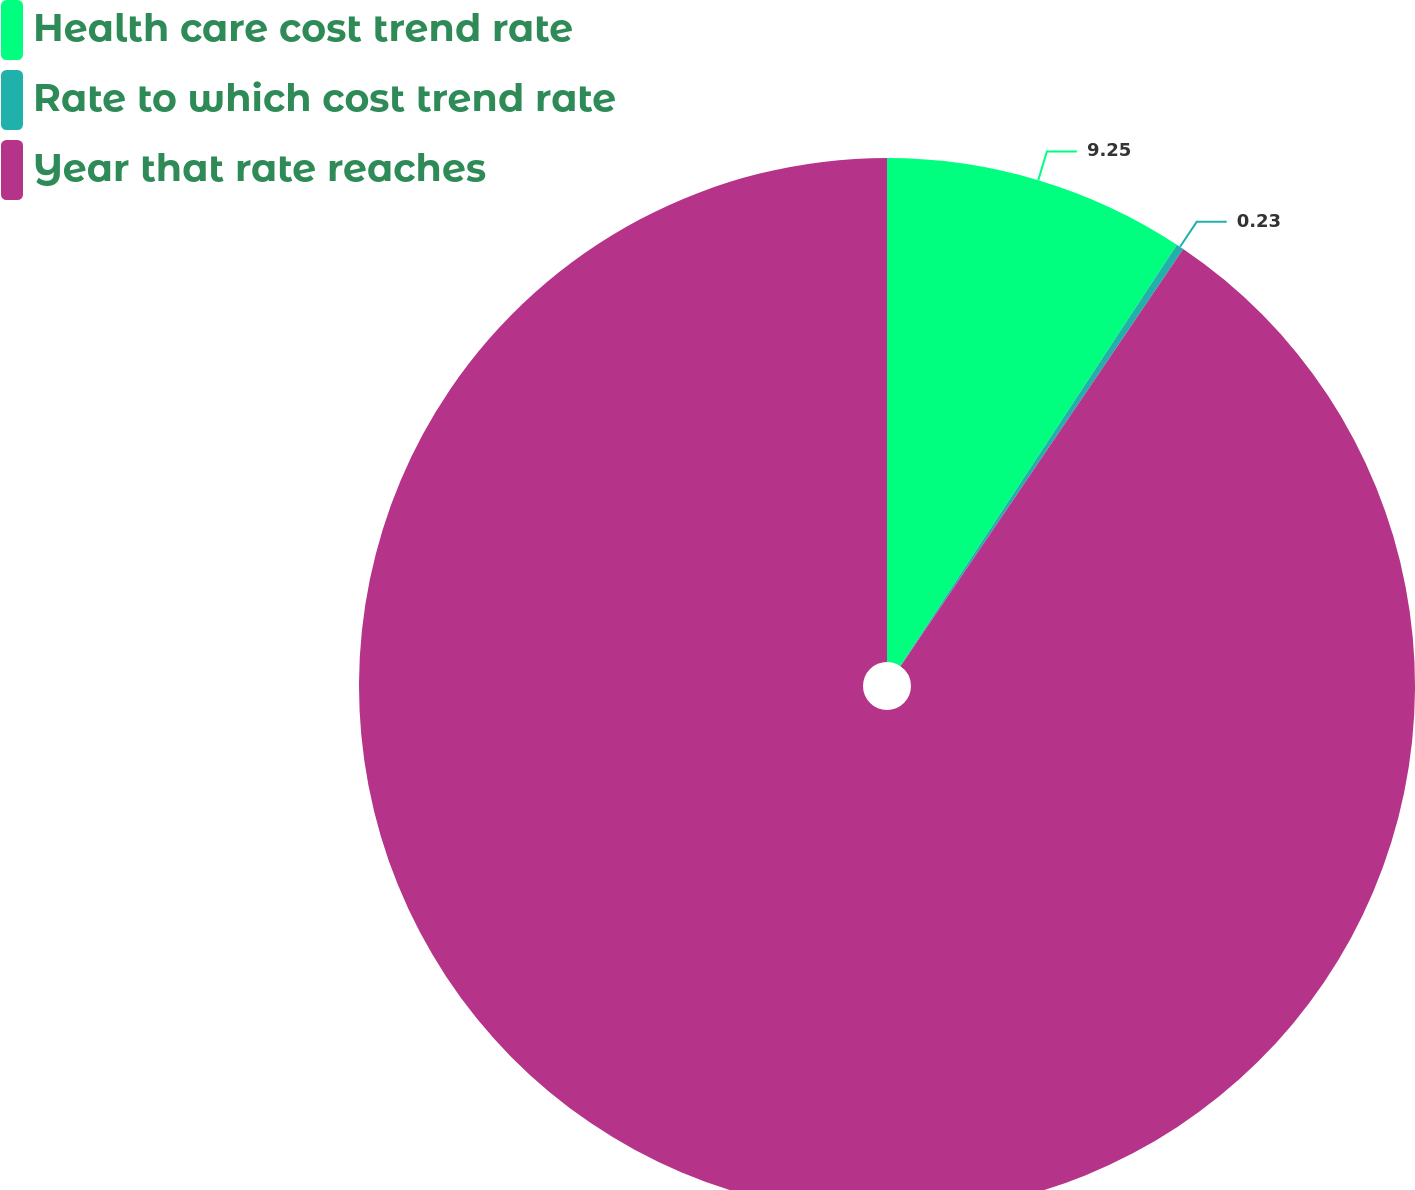Convert chart to OTSL. <chart><loc_0><loc_0><loc_500><loc_500><pie_chart><fcel>Health care cost trend rate<fcel>Rate to which cost trend rate<fcel>Year that rate reaches<nl><fcel>9.25%<fcel>0.23%<fcel>90.52%<nl></chart> 